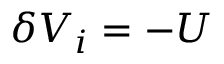Convert formula to latex. <formula><loc_0><loc_0><loc_500><loc_500>\delta V _ { i } = - U</formula> 